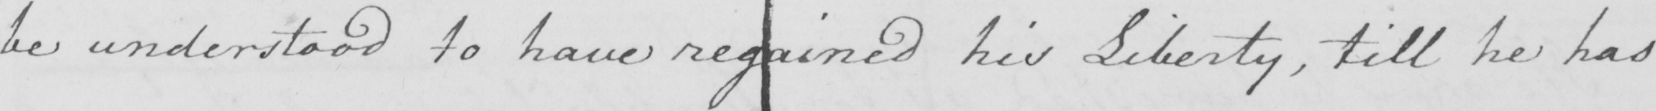What text is written in this handwritten line? be understood to have regained his Liberty , till he has 